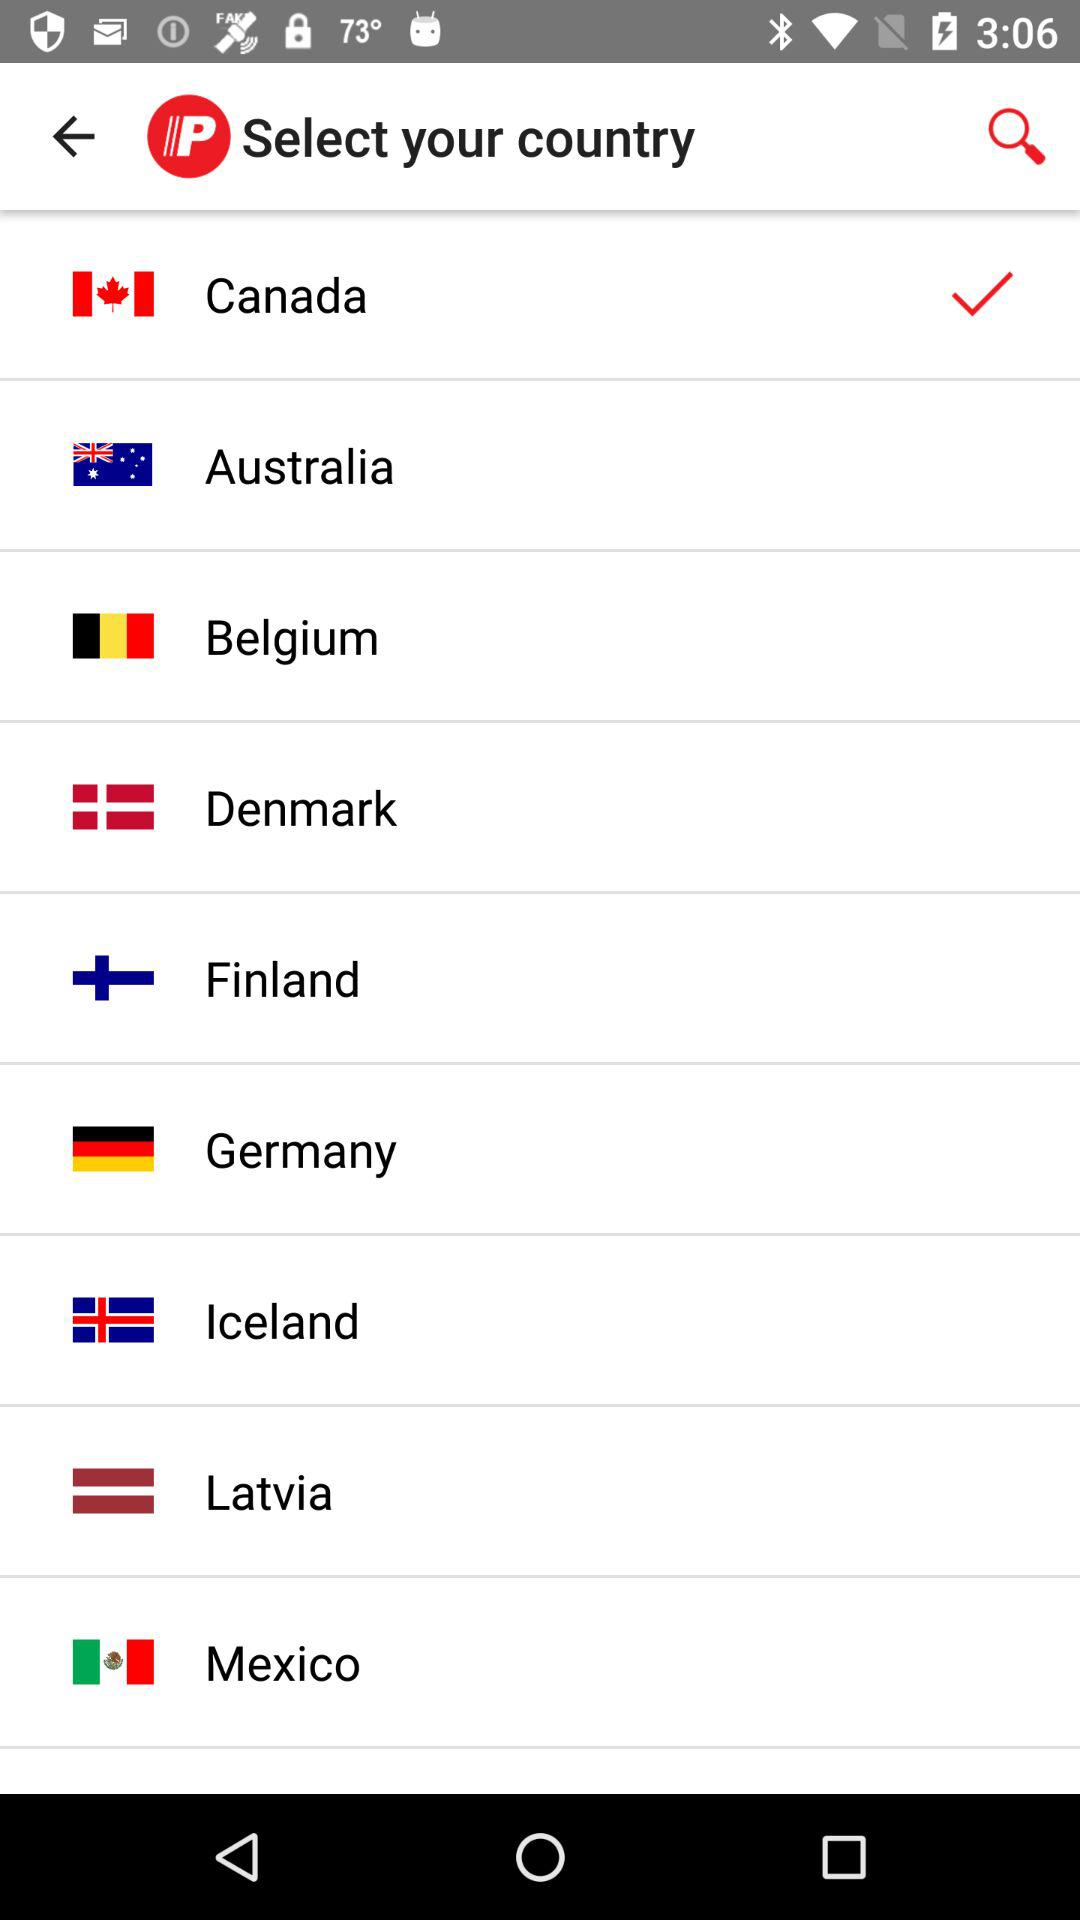Which country is selected? The selected country is Canada. 